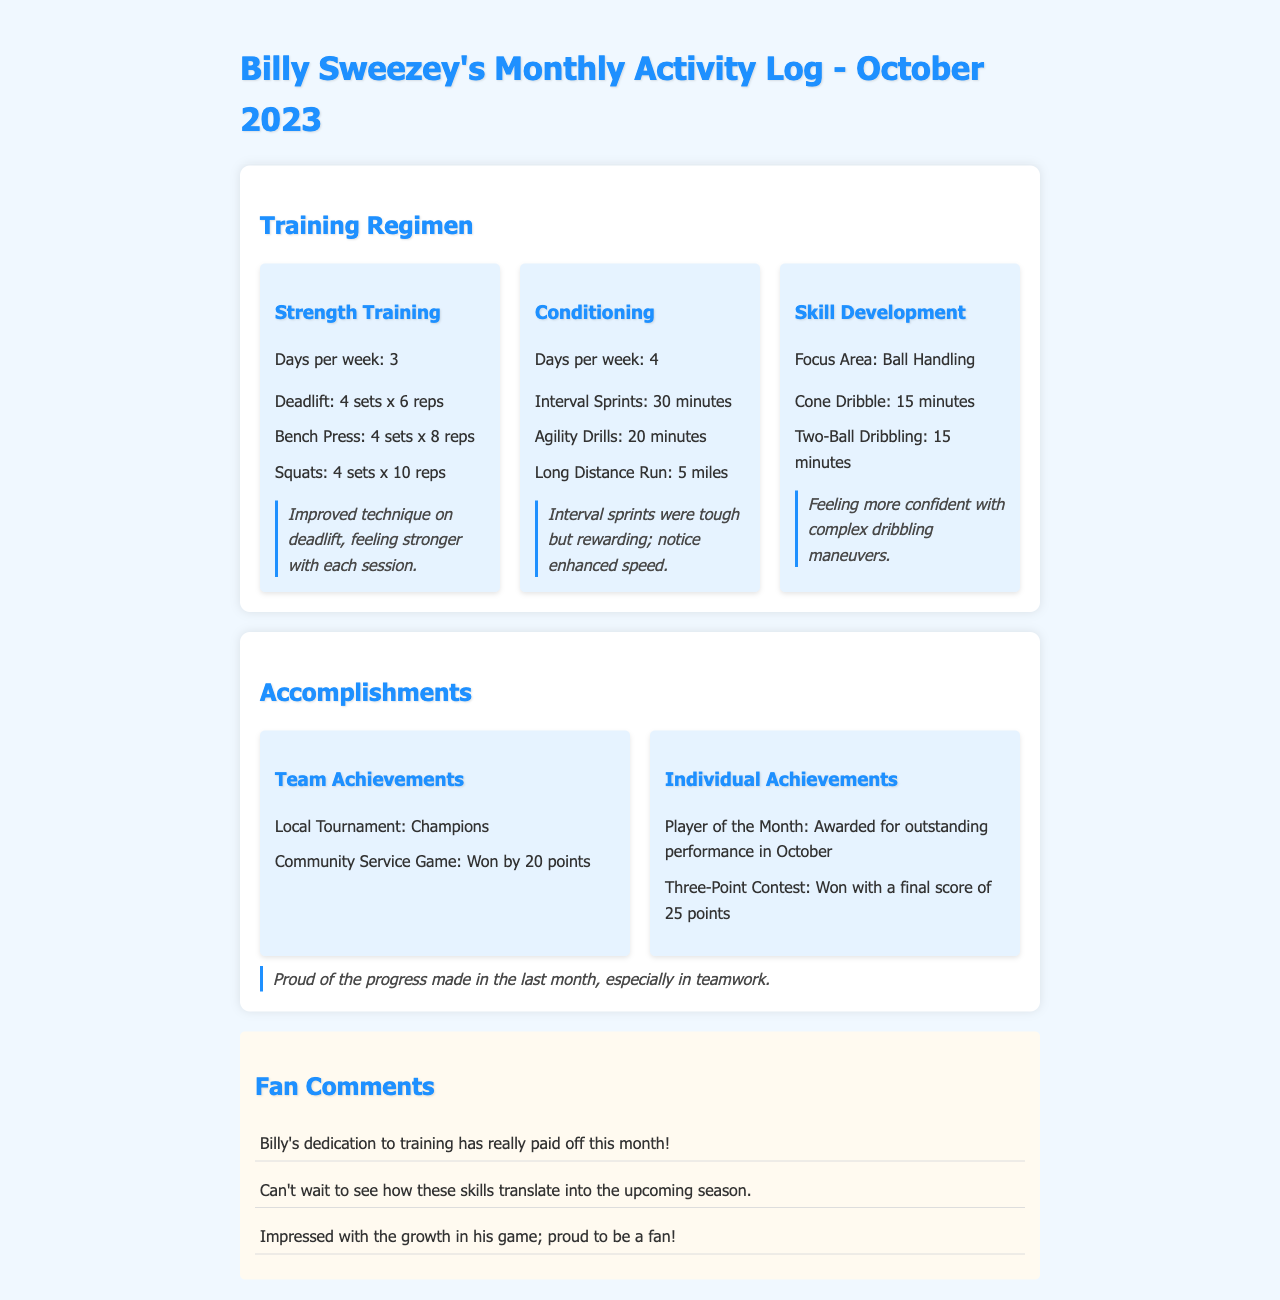What is the focus area for skill development? The document specifies the focus area for skill development is "Ball Handling."
Answer: Ball Handling How many days per week does Billy train for conditioning? According to the training regimen, conditioning is done 4 days per week.
Answer: 4 What was Billy's final score in the Three-Point Contest? The document states that Billy won the Three-Point Contest with a final score of 25 points.
Answer: 25 points Which team achievement did Billy's team accomplish in October? The document mentions that Billy's team was the "Champions" in a local tournament.
Answer: Champions What personal achievement did Billy earn for October? The document indicates that Billy was awarded "Player of the Month" for outstanding performance in October.
Answer: Player of the Month How many sets of squats does Billy perform in his strength training? The training regimen shows that he performs "4 sets x 10 reps" for squats.
Answer: 4 sets x 10 reps What improvement did Billy note in his deadlift technique? Billy noted that he has "Improved technique on deadlift."
Answer: Improved technique What type of drills does Billy conduct for agility training? The document lists "Agility Drills" as part of his conditioning routine.
Answer: Agility Drills 